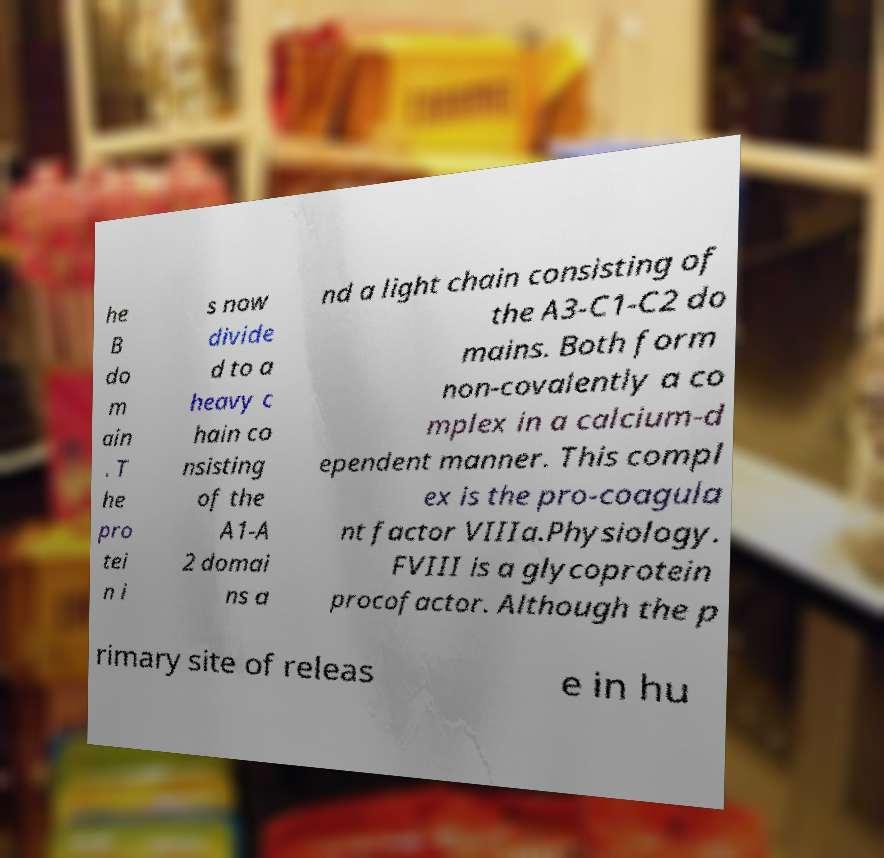I need the written content from this picture converted into text. Can you do that? he B do m ain . T he pro tei n i s now divide d to a heavy c hain co nsisting of the A1-A 2 domai ns a nd a light chain consisting of the A3-C1-C2 do mains. Both form non-covalently a co mplex in a calcium-d ependent manner. This compl ex is the pro-coagula nt factor VIIIa.Physiology. FVIII is a glycoprotein procofactor. Although the p rimary site of releas e in hu 